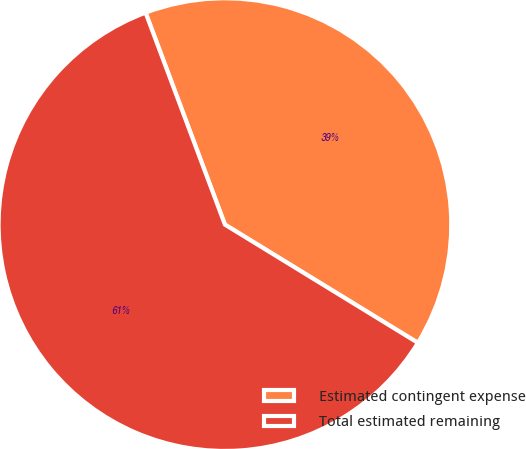<chart> <loc_0><loc_0><loc_500><loc_500><pie_chart><fcel>Estimated contingent expense<fcel>Total estimated remaining<nl><fcel>39.45%<fcel>60.55%<nl></chart> 